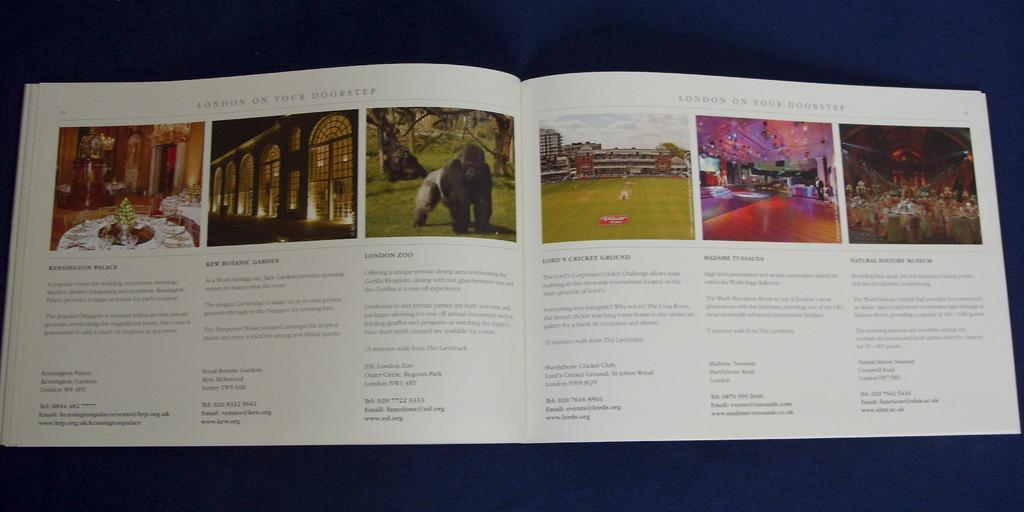<image>
Offer a succinct explanation of the picture presented. A book showcasing activities in London including zoos and historic locations. 